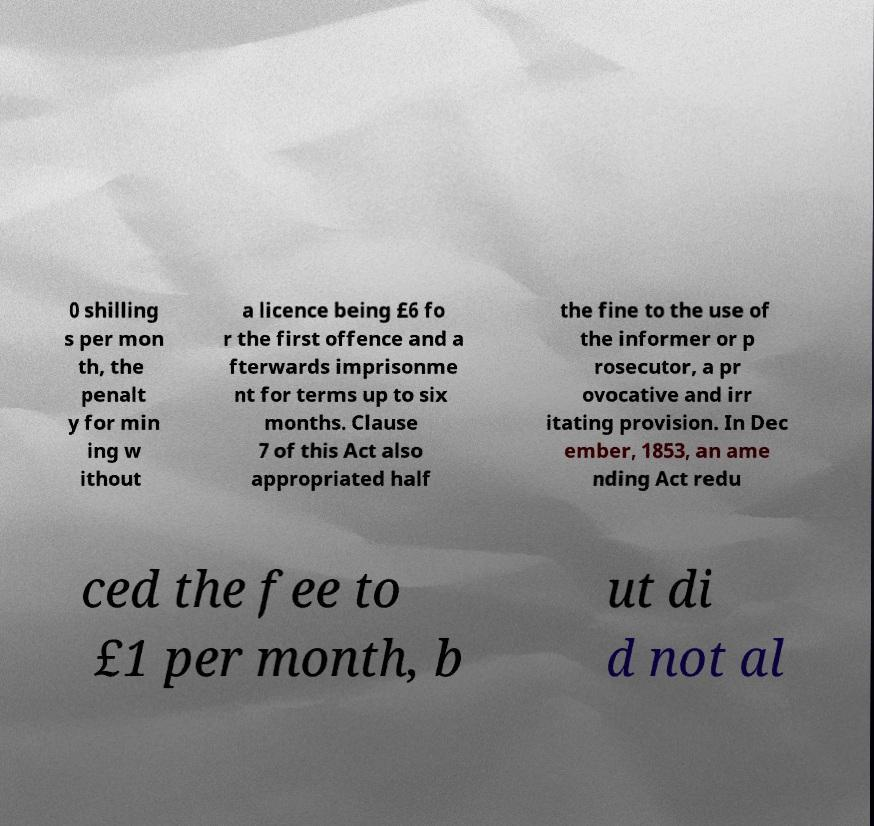Could you assist in decoding the text presented in this image and type it out clearly? 0 shilling s per mon th, the penalt y for min ing w ithout a licence being £6 fo r the first offence and a fterwards imprisonme nt for terms up to six months. Clause 7 of this Act also appropriated half the fine to the use of the informer or p rosecutor, a pr ovocative and irr itating provision. In Dec ember, 1853, an ame nding Act redu ced the fee to £1 per month, b ut di d not al 